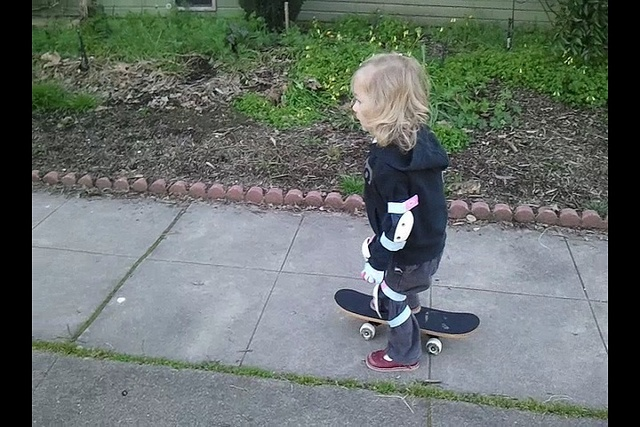Describe the objects in this image and their specific colors. I can see people in black, darkgray, and gray tones and skateboard in black, navy, darkgray, and gray tones in this image. 